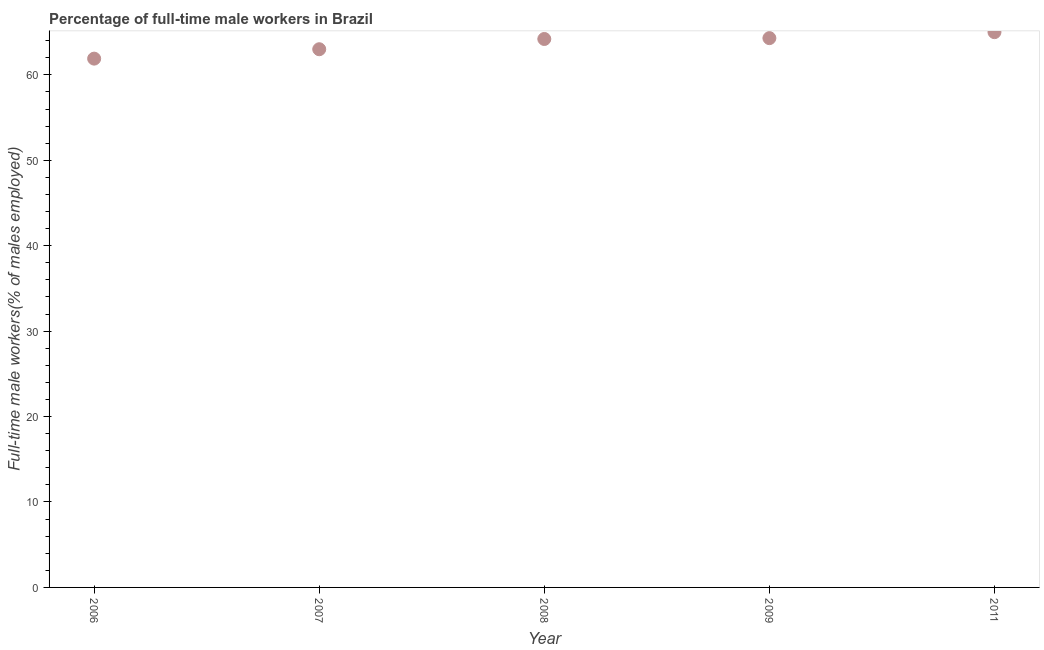What is the percentage of full-time male workers in 2011?
Provide a short and direct response. 65. Across all years, what is the minimum percentage of full-time male workers?
Give a very brief answer. 61.9. In which year was the percentage of full-time male workers maximum?
Ensure brevity in your answer.  2011. In which year was the percentage of full-time male workers minimum?
Provide a short and direct response. 2006. What is the sum of the percentage of full-time male workers?
Keep it short and to the point. 318.4. What is the difference between the percentage of full-time male workers in 2006 and 2007?
Keep it short and to the point. -1.1. What is the average percentage of full-time male workers per year?
Offer a terse response. 63.68. What is the median percentage of full-time male workers?
Your answer should be compact. 64.2. What is the ratio of the percentage of full-time male workers in 2006 to that in 2007?
Your response must be concise. 0.98. What is the difference between the highest and the second highest percentage of full-time male workers?
Make the answer very short. 0.7. Is the sum of the percentage of full-time male workers in 2006 and 2009 greater than the maximum percentage of full-time male workers across all years?
Offer a very short reply. Yes. What is the difference between the highest and the lowest percentage of full-time male workers?
Provide a short and direct response. 3.1. Does the percentage of full-time male workers monotonically increase over the years?
Offer a terse response. Yes. How many years are there in the graph?
Your answer should be compact. 5. Are the values on the major ticks of Y-axis written in scientific E-notation?
Offer a terse response. No. Does the graph contain grids?
Make the answer very short. No. What is the title of the graph?
Give a very brief answer. Percentage of full-time male workers in Brazil. What is the label or title of the Y-axis?
Provide a short and direct response. Full-time male workers(% of males employed). What is the Full-time male workers(% of males employed) in 2006?
Give a very brief answer. 61.9. What is the Full-time male workers(% of males employed) in 2007?
Provide a succinct answer. 63. What is the Full-time male workers(% of males employed) in 2008?
Offer a very short reply. 64.2. What is the Full-time male workers(% of males employed) in 2009?
Provide a succinct answer. 64.3. What is the difference between the Full-time male workers(% of males employed) in 2006 and 2007?
Your response must be concise. -1.1. What is the difference between the Full-time male workers(% of males employed) in 2006 and 2008?
Make the answer very short. -2.3. What is the difference between the Full-time male workers(% of males employed) in 2007 and 2009?
Offer a very short reply. -1.3. What is the difference between the Full-time male workers(% of males employed) in 2007 and 2011?
Offer a very short reply. -2. What is the difference between the Full-time male workers(% of males employed) in 2008 and 2009?
Offer a terse response. -0.1. What is the ratio of the Full-time male workers(% of males employed) in 2007 to that in 2011?
Your answer should be compact. 0.97. 